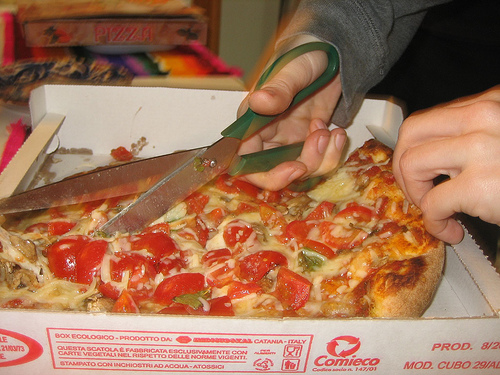<image>
Is there a pizza under the scissors? Yes. The pizza is positioned underneath the scissors, with the scissors above it in the vertical space. 